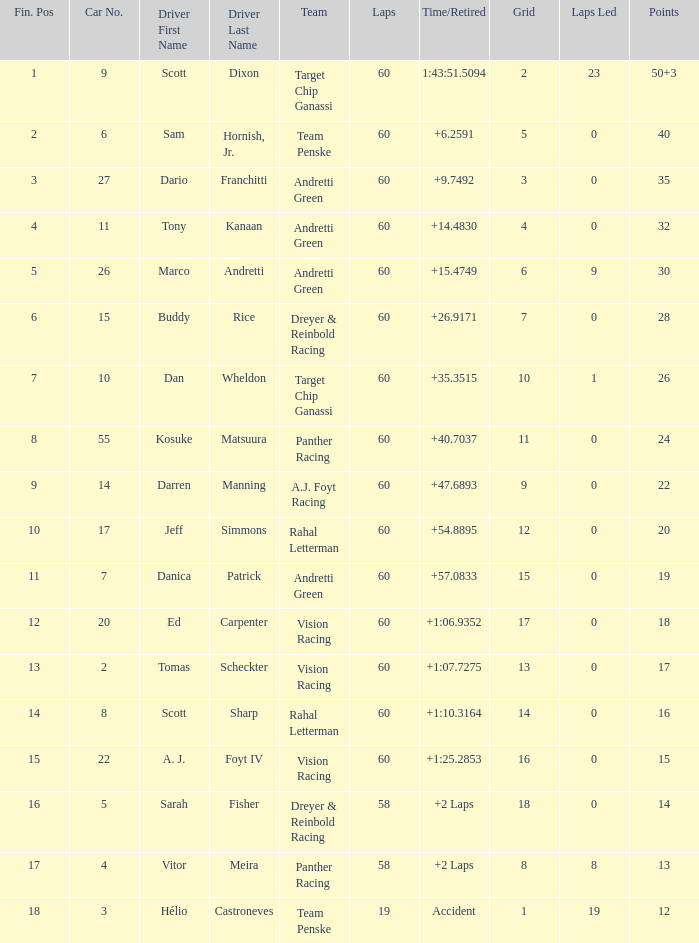Name the drive for points being 13 Vitor Meira. 